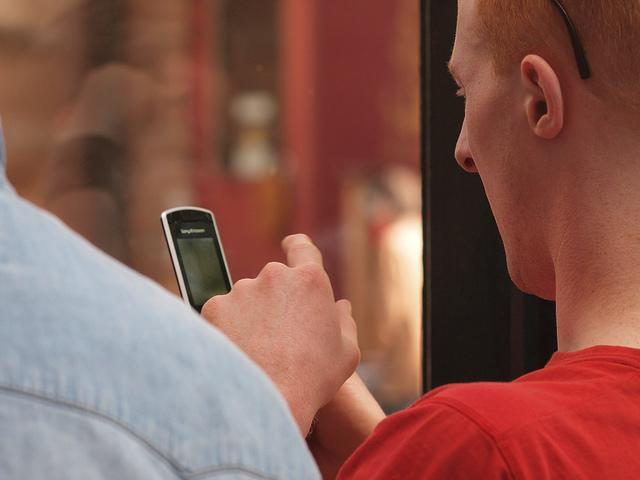The bald man with glasses is using what kind of phone?

Choices:
A) flip
B) iphone
C) blackberry
D) smart flip 